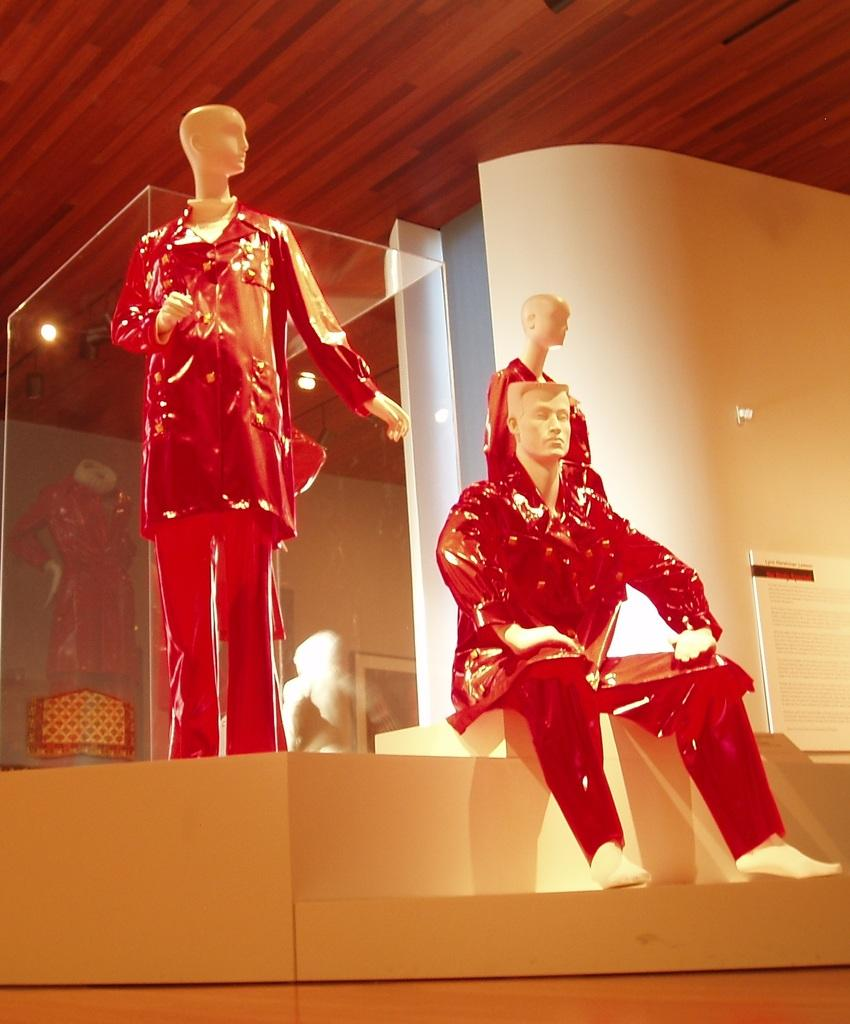What type of figures can be seen in the image? There are mannequins in the image. What object is present that can be used for displaying information or images? There is a board in the image. Where is the photo frame located in the image? The photo frame is on a wall in the image. What type of container is visible in the image? There is a glass container in the image. What type of lighting is present in the image? There is a roof with ceiling lights in the image. How many boats are docked near the mannequins in the image? There are no boats present in the image; it only features mannequins, a board, a photo frame, a glass container, and a roof with ceiling lights. 